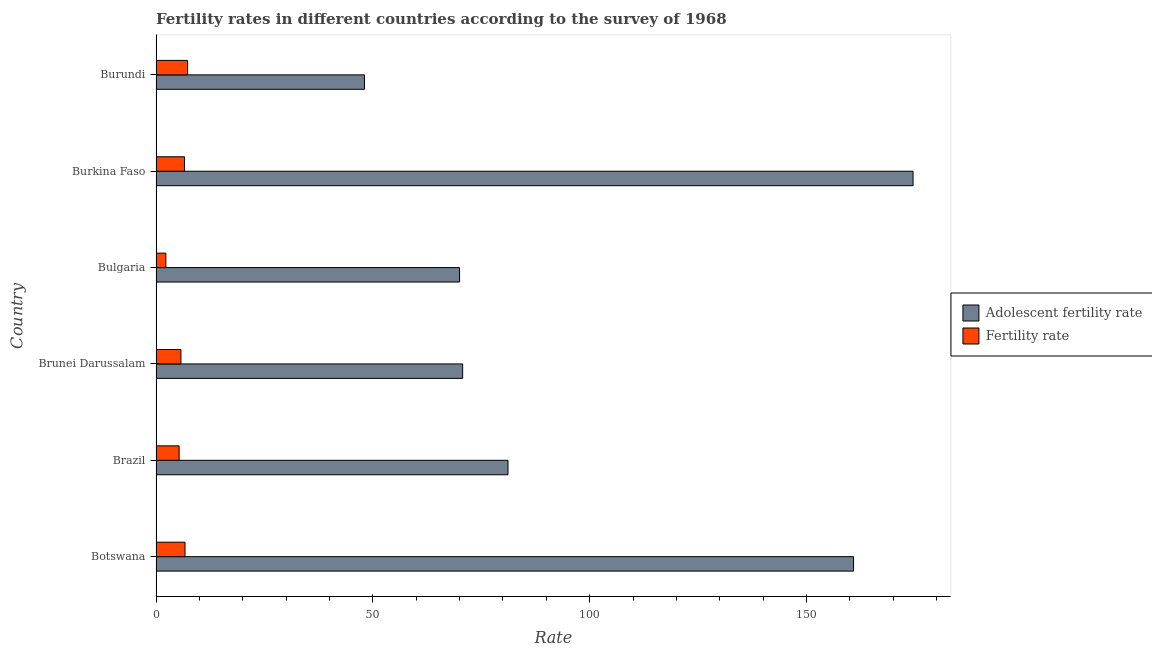What is the label of the 4th group of bars from the top?
Your answer should be very brief. Brunei Darussalam. What is the fertility rate in Bulgaria?
Offer a very short reply. 2.27. Across all countries, what is the maximum fertility rate?
Your answer should be compact. 7.27. Across all countries, what is the minimum fertility rate?
Offer a very short reply. 2.27. In which country was the adolescent fertility rate maximum?
Provide a short and direct response. Burkina Faso. What is the total adolescent fertility rate in the graph?
Keep it short and to the point. 605.39. What is the difference between the fertility rate in Brunei Darussalam and that in Burkina Faso?
Offer a very short reply. -0.82. What is the difference between the adolescent fertility rate in Burundi and the fertility rate in Burkina Faso?
Offer a terse response. 41.51. What is the average adolescent fertility rate per country?
Make the answer very short. 100.9. What is the difference between the fertility rate and adolescent fertility rate in Brunei Darussalam?
Ensure brevity in your answer.  -64.97. What is the ratio of the adolescent fertility rate in Botswana to that in Brunei Darussalam?
Provide a short and direct response. 2.27. What is the difference between the highest and the second highest fertility rate?
Offer a very short reply. 0.59. What does the 2nd bar from the top in Burundi represents?
Ensure brevity in your answer.  Adolescent fertility rate. What does the 1st bar from the bottom in Bulgaria represents?
Your answer should be compact. Adolescent fertility rate. How many countries are there in the graph?
Your answer should be compact. 6. What is the difference between two consecutive major ticks on the X-axis?
Your answer should be very brief. 50. Are the values on the major ticks of X-axis written in scientific E-notation?
Provide a short and direct response. No. Does the graph contain any zero values?
Keep it short and to the point. No. Does the graph contain grids?
Your answer should be compact. No. Where does the legend appear in the graph?
Provide a short and direct response. Center right. How many legend labels are there?
Offer a terse response. 2. How are the legend labels stacked?
Offer a very short reply. Vertical. What is the title of the graph?
Make the answer very short. Fertility rates in different countries according to the survey of 1968. What is the label or title of the X-axis?
Give a very brief answer. Rate. What is the Rate in Adolescent fertility rate in Botswana?
Offer a very short reply. 160.86. What is the Rate of Fertility rate in Botswana?
Provide a short and direct response. 6.69. What is the Rate of Adolescent fertility rate in Brazil?
Keep it short and to the point. 81.17. What is the Rate in Fertility rate in Brazil?
Provide a succinct answer. 5.33. What is the Rate of Adolescent fertility rate in Brunei Darussalam?
Provide a short and direct response. 70.71. What is the Rate in Fertility rate in Brunei Darussalam?
Give a very brief answer. 5.74. What is the Rate of Adolescent fertility rate in Bulgaria?
Make the answer very short. 70. What is the Rate in Fertility rate in Bulgaria?
Your answer should be very brief. 2.27. What is the Rate of Adolescent fertility rate in Burkina Faso?
Your response must be concise. 174.58. What is the Rate of Fertility rate in Burkina Faso?
Your answer should be compact. 6.56. What is the Rate in Adolescent fertility rate in Burundi?
Provide a succinct answer. 48.07. What is the Rate of Fertility rate in Burundi?
Ensure brevity in your answer.  7.27. Across all countries, what is the maximum Rate in Adolescent fertility rate?
Your answer should be very brief. 174.58. Across all countries, what is the maximum Rate in Fertility rate?
Offer a terse response. 7.27. Across all countries, what is the minimum Rate of Adolescent fertility rate?
Provide a succinct answer. 48.07. Across all countries, what is the minimum Rate in Fertility rate?
Provide a succinct answer. 2.27. What is the total Rate in Adolescent fertility rate in the graph?
Keep it short and to the point. 605.39. What is the total Rate of Fertility rate in the graph?
Provide a succinct answer. 33.86. What is the difference between the Rate in Adolescent fertility rate in Botswana and that in Brazil?
Keep it short and to the point. 79.69. What is the difference between the Rate of Fertility rate in Botswana and that in Brazil?
Give a very brief answer. 1.36. What is the difference between the Rate in Adolescent fertility rate in Botswana and that in Brunei Darussalam?
Your answer should be very brief. 90.15. What is the difference between the Rate in Fertility rate in Botswana and that in Brunei Darussalam?
Offer a terse response. 0.94. What is the difference between the Rate in Adolescent fertility rate in Botswana and that in Bulgaria?
Offer a very short reply. 90.86. What is the difference between the Rate of Fertility rate in Botswana and that in Bulgaria?
Provide a succinct answer. 4.42. What is the difference between the Rate in Adolescent fertility rate in Botswana and that in Burkina Faso?
Your response must be concise. -13.72. What is the difference between the Rate of Fertility rate in Botswana and that in Burkina Faso?
Keep it short and to the point. 0.12. What is the difference between the Rate of Adolescent fertility rate in Botswana and that in Burundi?
Keep it short and to the point. 112.79. What is the difference between the Rate in Fertility rate in Botswana and that in Burundi?
Your response must be concise. -0.59. What is the difference between the Rate of Adolescent fertility rate in Brazil and that in Brunei Darussalam?
Give a very brief answer. 10.46. What is the difference between the Rate of Fertility rate in Brazil and that in Brunei Darussalam?
Provide a succinct answer. -0.42. What is the difference between the Rate of Adolescent fertility rate in Brazil and that in Bulgaria?
Give a very brief answer. 11.17. What is the difference between the Rate of Fertility rate in Brazil and that in Bulgaria?
Provide a succinct answer. 3.06. What is the difference between the Rate of Adolescent fertility rate in Brazil and that in Burkina Faso?
Give a very brief answer. -93.41. What is the difference between the Rate in Fertility rate in Brazil and that in Burkina Faso?
Keep it short and to the point. -1.24. What is the difference between the Rate of Adolescent fertility rate in Brazil and that in Burundi?
Your answer should be very brief. 33.1. What is the difference between the Rate of Fertility rate in Brazil and that in Burundi?
Your answer should be compact. -1.95. What is the difference between the Rate of Adolescent fertility rate in Brunei Darussalam and that in Bulgaria?
Your answer should be compact. 0.71. What is the difference between the Rate of Fertility rate in Brunei Darussalam and that in Bulgaria?
Your answer should be compact. 3.47. What is the difference between the Rate of Adolescent fertility rate in Brunei Darussalam and that in Burkina Faso?
Offer a terse response. -103.87. What is the difference between the Rate in Fertility rate in Brunei Darussalam and that in Burkina Faso?
Make the answer very short. -0.82. What is the difference between the Rate in Adolescent fertility rate in Brunei Darussalam and that in Burundi?
Make the answer very short. 22.64. What is the difference between the Rate in Fertility rate in Brunei Darussalam and that in Burundi?
Give a very brief answer. -1.53. What is the difference between the Rate of Adolescent fertility rate in Bulgaria and that in Burkina Faso?
Provide a succinct answer. -104.58. What is the difference between the Rate in Fertility rate in Bulgaria and that in Burkina Faso?
Give a very brief answer. -4.29. What is the difference between the Rate of Adolescent fertility rate in Bulgaria and that in Burundi?
Make the answer very short. 21.93. What is the difference between the Rate of Fertility rate in Bulgaria and that in Burundi?
Your response must be concise. -5. What is the difference between the Rate of Adolescent fertility rate in Burkina Faso and that in Burundi?
Ensure brevity in your answer.  126.51. What is the difference between the Rate of Fertility rate in Burkina Faso and that in Burundi?
Offer a very short reply. -0.71. What is the difference between the Rate of Adolescent fertility rate in Botswana and the Rate of Fertility rate in Brazil?
Offer a very short reply. 155.54. What is the difference between the Rate in Adolescent fertility rate in Botswana and the Rate in Fertility rate in Brunei Darussalam?
Your answer should be very brief. 155.12. What is the difference between the Rate in Adolescent fertility rate in Botswana and the Rate in Fertility rate in Bulgaria?
Your answer should be compact. 158.59. What is the difference between the Rate of Adolescent fertility rate in Botswana and the Rate of Fertility rate in Burkina Faso?
Your answer should be very brief. 154.3. What is the difference between the Rate of Adolescent fertility rate in Botswana and the Rate of Fertility rate in Burundi?
Provide a succinct answer. 153.59. What is the difference between the Rate of Adolescent fertility rate in Brazil and the Rate of Fertility rate in Brunei Darussalam?
Offer a very short reply. 75.43. What is the difference between the Rate in Adolescent fertility rate in Brazil and the Rate in Fertility rate in Bulgaria?
Ensure brevity in your answer.  78.9. What is the difference between the Rate in Adolescent fertility rate in Brazil and the Rate in Fertility rate in Burkina Faso?
Your answer should be very brief. 74.61. What is the difference between the Rate in Adolescent fertility rate in Brazil and the Rate in Fertility rate in Burundi?
Provide a short and direct response. 73.9. What is the difference between the Rate of Adolescent fertility rate in Brunei Darussalam and the Rate of Fertility rate in Bulgaria?
Your answer should be very brief. 68.44. What is the difference between the Rate in Adolescent fertility rate in Brunei Darussalam and the Rate in Fertility rate in Burkina Faso?
Provide a short and direct response. 64.15. What is the difference between the Rate in Adolescent fertility rate in Brunei Darussalam and the Rate in Fertility rate in Burundi?
Ensure brevity in your answer.  63.44. What is the difference between the Rate of Adolescent fertility rate in Bulgaria and the Rate of Fertility rate in Burkina Faso?
Your answer should be compact. 63.44. What is the difference between the Rate in Adolescent fertility rate in Bulgaria and the Rate in Fertility rate in Burundi?
Offer a terse response. 62.73. What is the difference between the Rate of Adolescent fertility rate in Burkina Faso and the Rate of Fertility rate in Burundi?
Offer a very short reply. 167.31. What is the average Rate in Adolescent fertility rate per country?
Your answer should be very brief. 100.9. What is the average Rate of Fertility rate per country?
Provide a short and direct response. 5.64. What is the difference between the Rate of Adolescent fertility rate and Rate of Fertility rate in Botswana?
Make the answer very short. 154.18. What is the difference between the Rate of Adolescent fertility rate and Rate of Fertility rate in Brazil?
Your answer should be very brief. 75.84. What is the difference between the Rate in Adolescent fertility rate and Rate in Fertility rate in Brunei Darussalam?
Keep it short and to the point. 64.97. What is the difference between the Rate in Adolescent fertility rate and Rate in Fertility rate in Bulgaria?
Your response must be concise. 67.73. What is the difference between the Rate of Adolescent fertility rate and Rate of Fertility rate in Burkina Faso?
Your answer should be compact. 168.02. What is the difference between the Rate of Adolescent fertility rate and Rate of Fertility rate in Burundi?
Make the answer very short. 40.8. What is the ratio of the Rate of Adolescent fertility rate in Botswana to that in Brazil?
Provide a succinct answer. 1.98. What is the ratio of the Rate in Fertility rate in Botswana to that in Brazil?
Ensure brevity in your answer.  1.26. What is the ratio of the Rate in Adolescent fertility rate in Botswana to that in Brunei Darussalam?
Offer a terse response. 2.27. What is the ratio of the Rate of Fertility rate in Botswana to that in Brunei Darussalam?
Give a very brief answer. 1.16. What is the ratio of the Rate in Adolescent fertility rate in Botswana to that in Bulgaria?
Your answer should be compact. 2.3. What is the ratio of the Rate in Fertility rate in Botswana to that in Bulgaria?
Give a very brief answer. 2.95. What is the ratio of the Rate of Adolescent fertility rate in Botswana to that in Burkina Faso?
Your response must be concise. 0.92. What is the ratio of the Rate of Fertility rate in Botswana to that in Burkina Faso?
Provide a succinct answer. 1.02. What is the ratio of the Rate in Adolescent fertility rate in Botswana to that in Burundi?
Keep it short and to the point. 3.35. What is the ratio of the Rate in Fertility rate in Botswana to that in Burundi?
Ensure brevity in your answer.  0.92. What is the ratio of the Rate of Adolescent fertility rate in Brazil to that in Brunei Darussalam?
Your response must be concise. 1.15. What is the ratio of the Rate of Fertility rate in Brazil to that in Brunei Darussalam?
Your answer should be very brief. 0.93. What is the ratio of the Rate of Adolescent fertility rate in Brazil to that in Bulgaria?
Your response must be concise. 1.16. What is the ratio of the Rate of Fertility rate in Brazil to that in Bulgaria?
Make the answer very short. 2.35. What is the ratio of the Rate of Adolescent fertility rate in Brazil to that in Burkina Faso?
Provide a succinct answer. 0.46. What is the ratio of the Rate in Fertility rate in Brazil to that in Burkina Faso?
Your answer should be compact. 0.81. What is the ratio of the Rate of Adolescent fertility rate in Brazil to that in Burundi?
Ensure brevity in your answer.  1.69. What is the ratio of the Rate of Fertility rate in Brazil to that in Burundi?
Your response must be concise. 0.73. What is the ratio of the Rate of Fertility rate in Brunei Darussalam to that in Bulgaria?
Ensure brevity in your answer.  2.53. What is the ratio of the Rate of Adolescent fertility rate in Brunei Darussalam to that in Burkina Faso?
Ensure brevity in your answer.  0.41. What is the ratio of the Rate of Fertility rate in Brunei Darussalam to that in Burkina Faso?
Your answer should be compact. 0.87. What is the ratio of the Rate in Adolescent fertility rate in Brunei Darussalam to that in Burundi?
Your answer should be compact. 1.47. What is the ratio of the Rate in Fertility rate in Brunei Darussalam to that in Burundi?
Your answer should be very brief. 0.79. What is the ratio of the Rate in Adolescent fertility rate in Bulgaria to that in Burkina Faso?
Your response must be concise. 0.4. What is the ratio of the Rate of Fertility rate in Bulgaria to that in Burkina Faso?
Ensure brevity in your answer.  0.35. What is the ratio of the Rate of Adolescent fertility rate in Bulgaria to that in Burundi?
Your answer should be very brief. 1.46. What is the ratio of the Rate in Fertility rate in Bulgaria to that in Burundi?
Your response must be concise. 0.31. What is the ratio of the Rate in Adolescent fertility rate in Burkina Faso to that in Burundi?
Make the answer very short. 3.63. What is the ratio of the Rate in Fertility rate in Burkina Faso to that in Burundi?
Ensure brevity in your answer.  0.9. What is the difference between the highest and the second highest Rate of Adolescent fertility rate?
Keep it short and to the point. 13.72. What is the difference between the highest and the second highest Rate of Fertility rate?
Give a very brief answer. 0.59. What is the difference between the highest and the lowest Rate in Adolescent fertility rate?
Provide a succinct answer. 126.51. What is the difference between the highest and the lowest Rate of Fertility rate?
Offer a terse response. 5. 